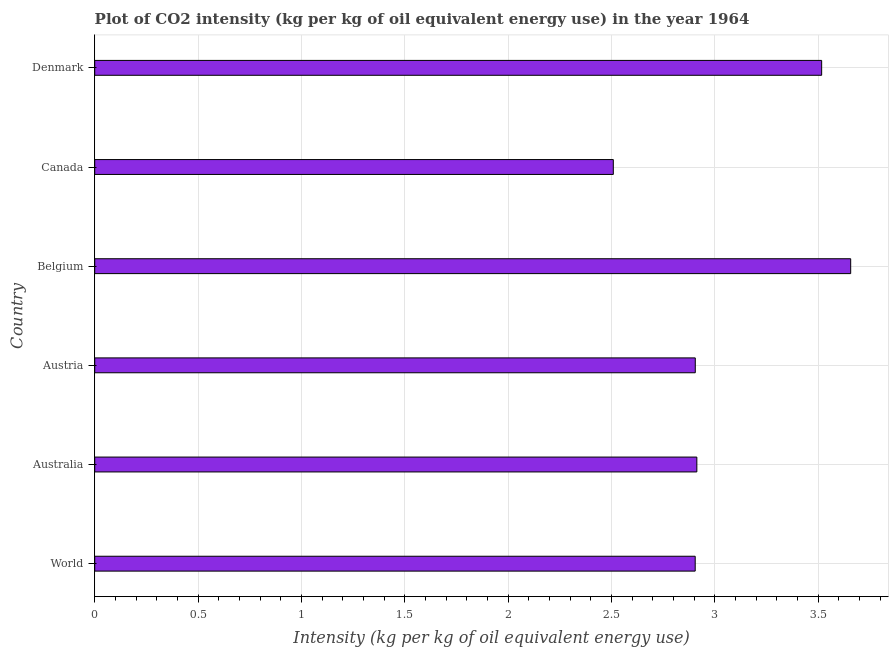What is the title of the graph?
Your answer should be very brief. Plot of CO2 intensity (kg per kg of oil equivalent energy use) in the year 1964. What is the label or title of the X-axis?
Give a very brief answer. Intensity (kg per kg of oil equivalent energy use). What is the label or title of the Y-axis?
Give a very brief answer. Country. What is the co2 intensity in Denmark?
Offer a terse response. 3.52. Across all countries, what is the maximum co2 intensity?
Offer a terse response. 3.66. Across all countries, what is the minimum co2 intensity?
Keep it short and to the point. 2.51. In which country was the co2 intensity maximum?
Give a very brief answer. Belgium. In which country was the co2 intensity minimum?
Your response must be concise. Canada. What is the sum of the co2 intensity?
Give a very brief answer. 18.41. What is the difference between the co2 intensity in Australia and Belgium?
Offer a terse response. -0.74. What is the average co2 intensity per country?
Give a very brief answer. 3.07. What is the median co2 intensity?
Your response must be concise. 2.91. What is the ratio of the co2 intensity in Australia to that in Belgium?
Your response must be concise. 0.8. Is the co2 intensity in Australia less than that in Canada?
Ensure brevity in your answer.  No. What is the difference between the highest and the second highest co2 intensity?
Give a very brief answer. 0.14. Is the sum of the co2 intensity in Austria and Belgium greater than the maximum co2 intensity across all countries?
Ensure brevity in your answer.  Yes. What is the difference between the highest and the lowest co2 intensity?
Provide a succinct answer. 1.15. In how many countries, is the co2 intensity greater than the average co2 intensity taken over all countries?
Ensure brevity in your answer.  2. How many bars are there?
Your response must be concise. 6. How many countries are there in the graph?
Offer a terse response. 6. What is the difference between two consecutive major ticks on the X-axis?
Provide a short and direct response. 0.5. What is the Intensity (kg per kg of oil equivalent energy use) of World?
Keep it short and to the point. 2.91. What is the Intensity (kg per kg of oil equivalent energy use) of Australia?
Offer a terse response. 2.91. What is the Intensity (kg per kg of oil equivalent energy use) in Austria?
Your response must be concise. 2.91. What is the Intensity (kg per kg of oil equivalent energy use) of Belgium?
Provide a short and direct response. 3.66. What is the Intensity (kg per kg of oil equivalent energy use) in Canada?
Give a very brief answer. 2.51. What is the Intensity (kg per kg of oil equivalent energy use) of Denmark?
Keep it short and to the point. 3.52. What is the difference between the Intensity (kg per kg of oil equivalent energy use) in World and Australia?
Provide a succinct answer. -0.01. What is the difference between the Intensity (kg per kg of oil equivalent energy use) in World and Austria?
Give a very brief answer. -0. What is the difference between the Intensity (kg per kg of oil equivalent energy use) in World and Belgium?
Keep it short and to the point. -0.75. What is the difference between the Intensity (kg per kg of oil equivalent energy use) in World and Canada?
Your response must be concise. 0.4. What is the difference between the Intensity (kg per kg of oil equivalent energy use) in World and Denmark?
Ensure brevity in your answer.  -0.61. What is the difference between the Intensity (kg per kg of oil equivalent energy use) in Australia and Austria?
Provide a short and direct response. 0.01. What is the difference between the Intensity (kg per kg of oil equivalent energy use) in Australia and Belgium?
Provide a short and direct response. -0.74. What is the difference between the Intensity (kg per kg of oil equivalent energy use) in Australia and Canada?
Offer a terse response. 0.4. What is the difference between the Intensity (kg per kg of oil equivalent energy use) in Australia and Denmark?
Offer a very short reply. -0.6. What is the difference between the Intensity (kg per kg of oil equivalent energy use) in Austria and Belgium?
Make the answer very short. -0.75. What is the difference between the Intensity (kg per kg of oil equivalent energy use) in Austria and Canada?
Ensure brevity in your answer.  0.4. What is the difference between the Intensity (kg per kg of oil equivalent energy use) in Austria and Denmark?
Offer a very short reply. -0.61. What is the difference between the Intensity (kg per kg of oil equivalent energy use) in Belgium and Canada?
Make the answer very short. 1.15. What is the difference between the Intensity (kg per kg of oil equivalent energy use) in Belgium and Denmark?
Offer a terse response. 0.14. What is the difference between the Intensity (kg per kg of oil equivalent energy use) in Canada and Denmark?
Ensure brevity in your answer.  -1.01. What is the ratio of the Intensity (kg per kg of oil equivalent energy use) in World to that in Belgium?
Give a very brief answer. 0.79. What is the ratio of the Intensity (kg per kg of oil equivalent energy use) in World to that in Canada?
Provide a short and direct response. 1.16. What is the ratio of the Intensity (kg per kg of oil equivalent energy use) in World to that in Denmark?
Your answer should be very brief. 0.83. What is the ratio of the Intensity (kg per kg of oil equivalent energy use) in Australia to that in Austria?
Your answer should be very brief. 1. What is the ratio of the Intensity (kg per kg of oil equivalent energy use) in Australia to that in Belgium?
Give a very brief answer. 0.8. What is the ratio of the Intensity (kg per kg of oil equivalent energy use) in Australia to that in Canada?
Make the answer very short. 1.16. What is the ratio of the Intensity (kg per kg of oil equivalent energy use) in Australia to that in Denmark?
Offer a very short reply. 0.83. What is the ratio of the Intensity (kg per kg of oil equivalent energy use) in Austria to that in Belgium?
Your response must be concise. 0.79. What is the ratio of the Intensity (kg per kg of oil equivalent energy use) in Austria to that in Canada?
Keep it short and to the point. 1.16. What is the ratio of the Intensity (kg per kg of oil equivalent energy use) in Austria to that in Denmark?
Keep it short and to the point. 0.83. What is the ratio of the Intensity (kg per kg of oil equivalent energy use) in Belgium to that in Canada?
Give a very brief answer. 1.46. What is the ratio of the Intensity (kg per kg of oil equivalent energy use) in Belgium to that in Denmark?
Ensure brevity in your answer.  1.04. What is the ratio of the Intensity (kg per kg of oil equivalent energy use) in Canada to that in Denmark?
Make the answer very short. 0.71. 